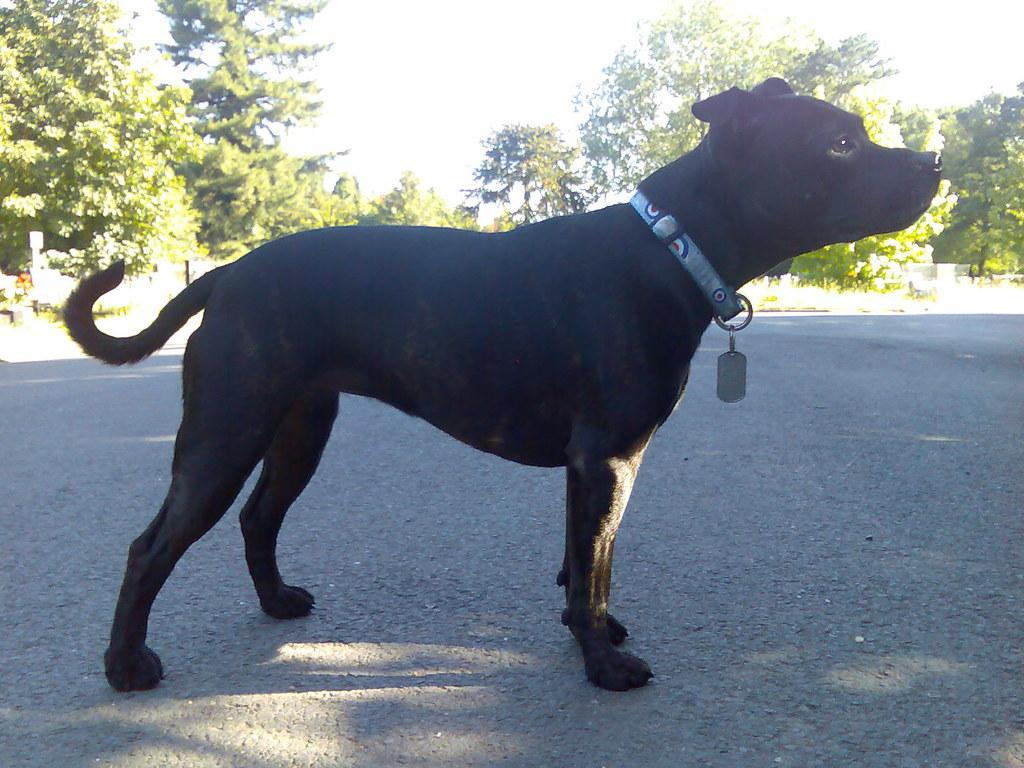What type of animal is in the image? There is a black dog in the image. Where is the dog located in the image? The dog is standing on the road. What can be seen in the background of the image? There are trees visible in the background of the image. What brand of toothpaste does the dog use in the image? There is no toothpaste present in the image, and the dog's personal hygiene habits are not mentioned. 